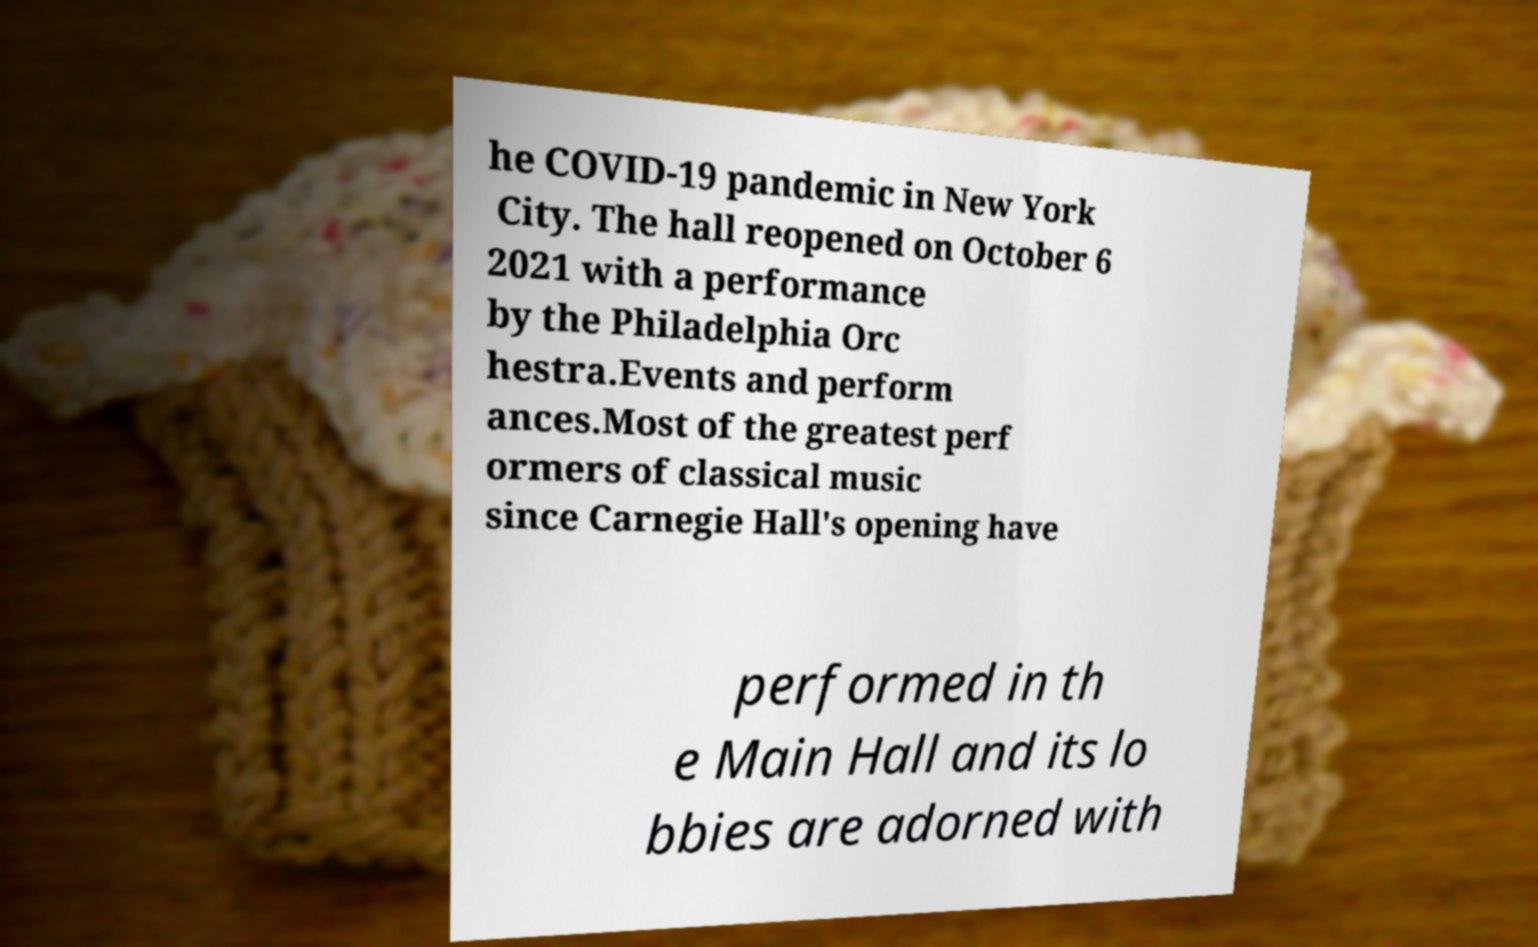Please read and relay the text visible in this image. What does it say? he COVID-19 pandemic in New York City. The hall reopened on October 6 2021 with a performance by the Philadelphia Orc hestra.Events and perform ances.Most of the greatest perf ormers of classical music since Carnegie Hall's opening have performed in th e Main Hall and its lo bbies are adorned with 